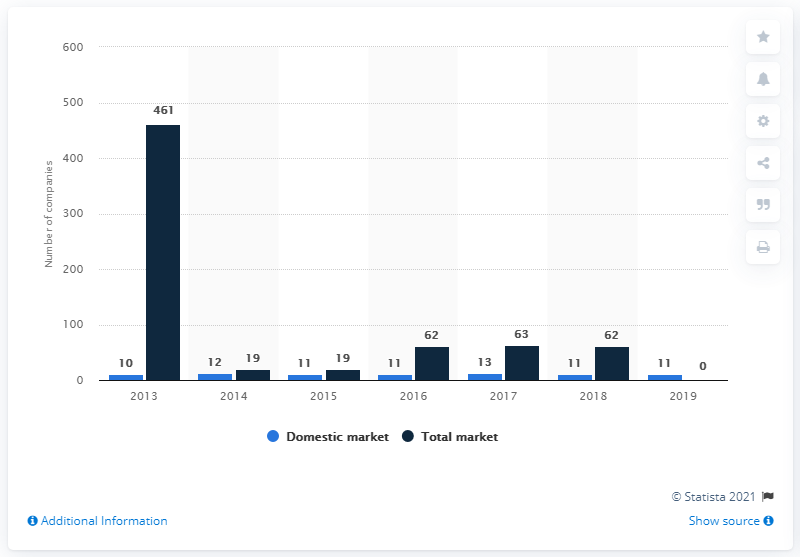Outline some significant characteristics in this image. There were 62 insurance companies operating in Malta's market in 2018. In 2019, there were 11 companies operating in Malta's insurance market. 